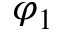Convert formula to latex. <formula><loc_0><loc_0><loc_500><loc_500>\varphi _ { 1 }</formula> 